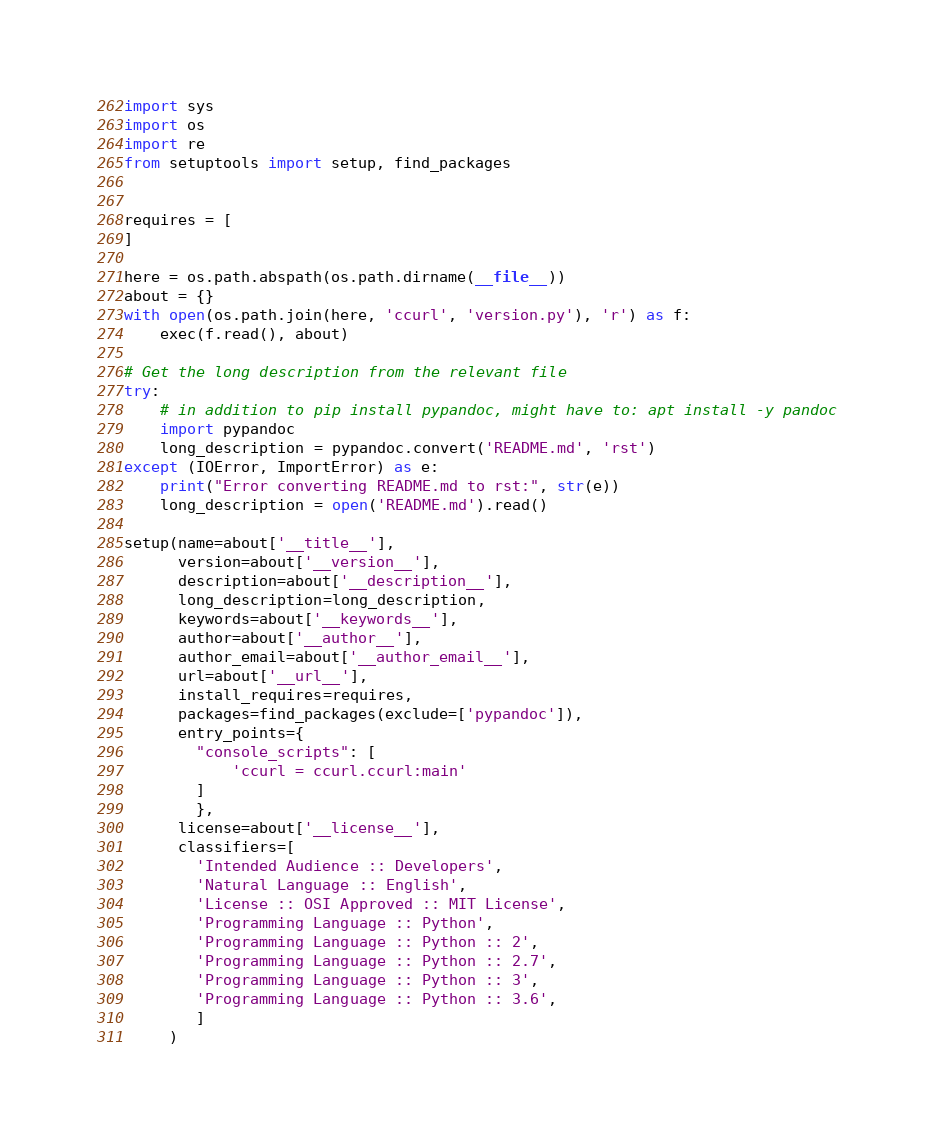Convert code to text. <code><loc_0><loc_0><loc_500><loc_500><_Python_>import sys
import os
import re
from setuptools import setup, find_packages


requires = [
]

here = os.path.abspath(os.path.dirname(__file__))
about = {}
with open(os.path.join(here, 'ccurl', 'version.py'), 'r') as f:
    exec(f.read(), about)

# Get the long description from the relevant file
try:
    # in addition to pip install pypandoc, might have to: apt install -y pandoc
    import pypandoc
    long_description = pypandoc.convert('README.md', 'rst')
except (IOError, ImportError) as e:
    print("Error converting README.md to rst:", str(e))
    long_description = open('README.md').read()

setup(name=about['__title__'],
      version=about['__version__'],
      description=about['__description__'],
      long_description=long_description,
      keywords=about['__keywords__'],
      author=about['__author__'],
      author_email=about['__author_email__'],
      url=about['__url__'],
      install_requires=requires,
      packages=find_packages(exclude=['pypandoc']),
      entry_points={
        "console_scripts": [
            'ccurl = ccurl.ccurl:main'
        ]
        },
      license=about['__license__'],
      classifiers=[
        'Intended Audience :: Developers',
        'Natural Language :: English',
        'License :: OSI Approved :: MIT License',
        'Programming Language :: Python',
        'Programming Language :: Python :: 2',
        'Programming Language :: Python :: 2.7',
        'Programming Language :: Python :: 3',
        'Programming Language :: Python :: 3.6',
        ]
     )
</code> 